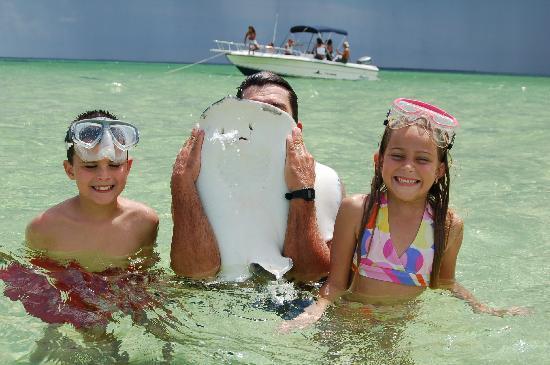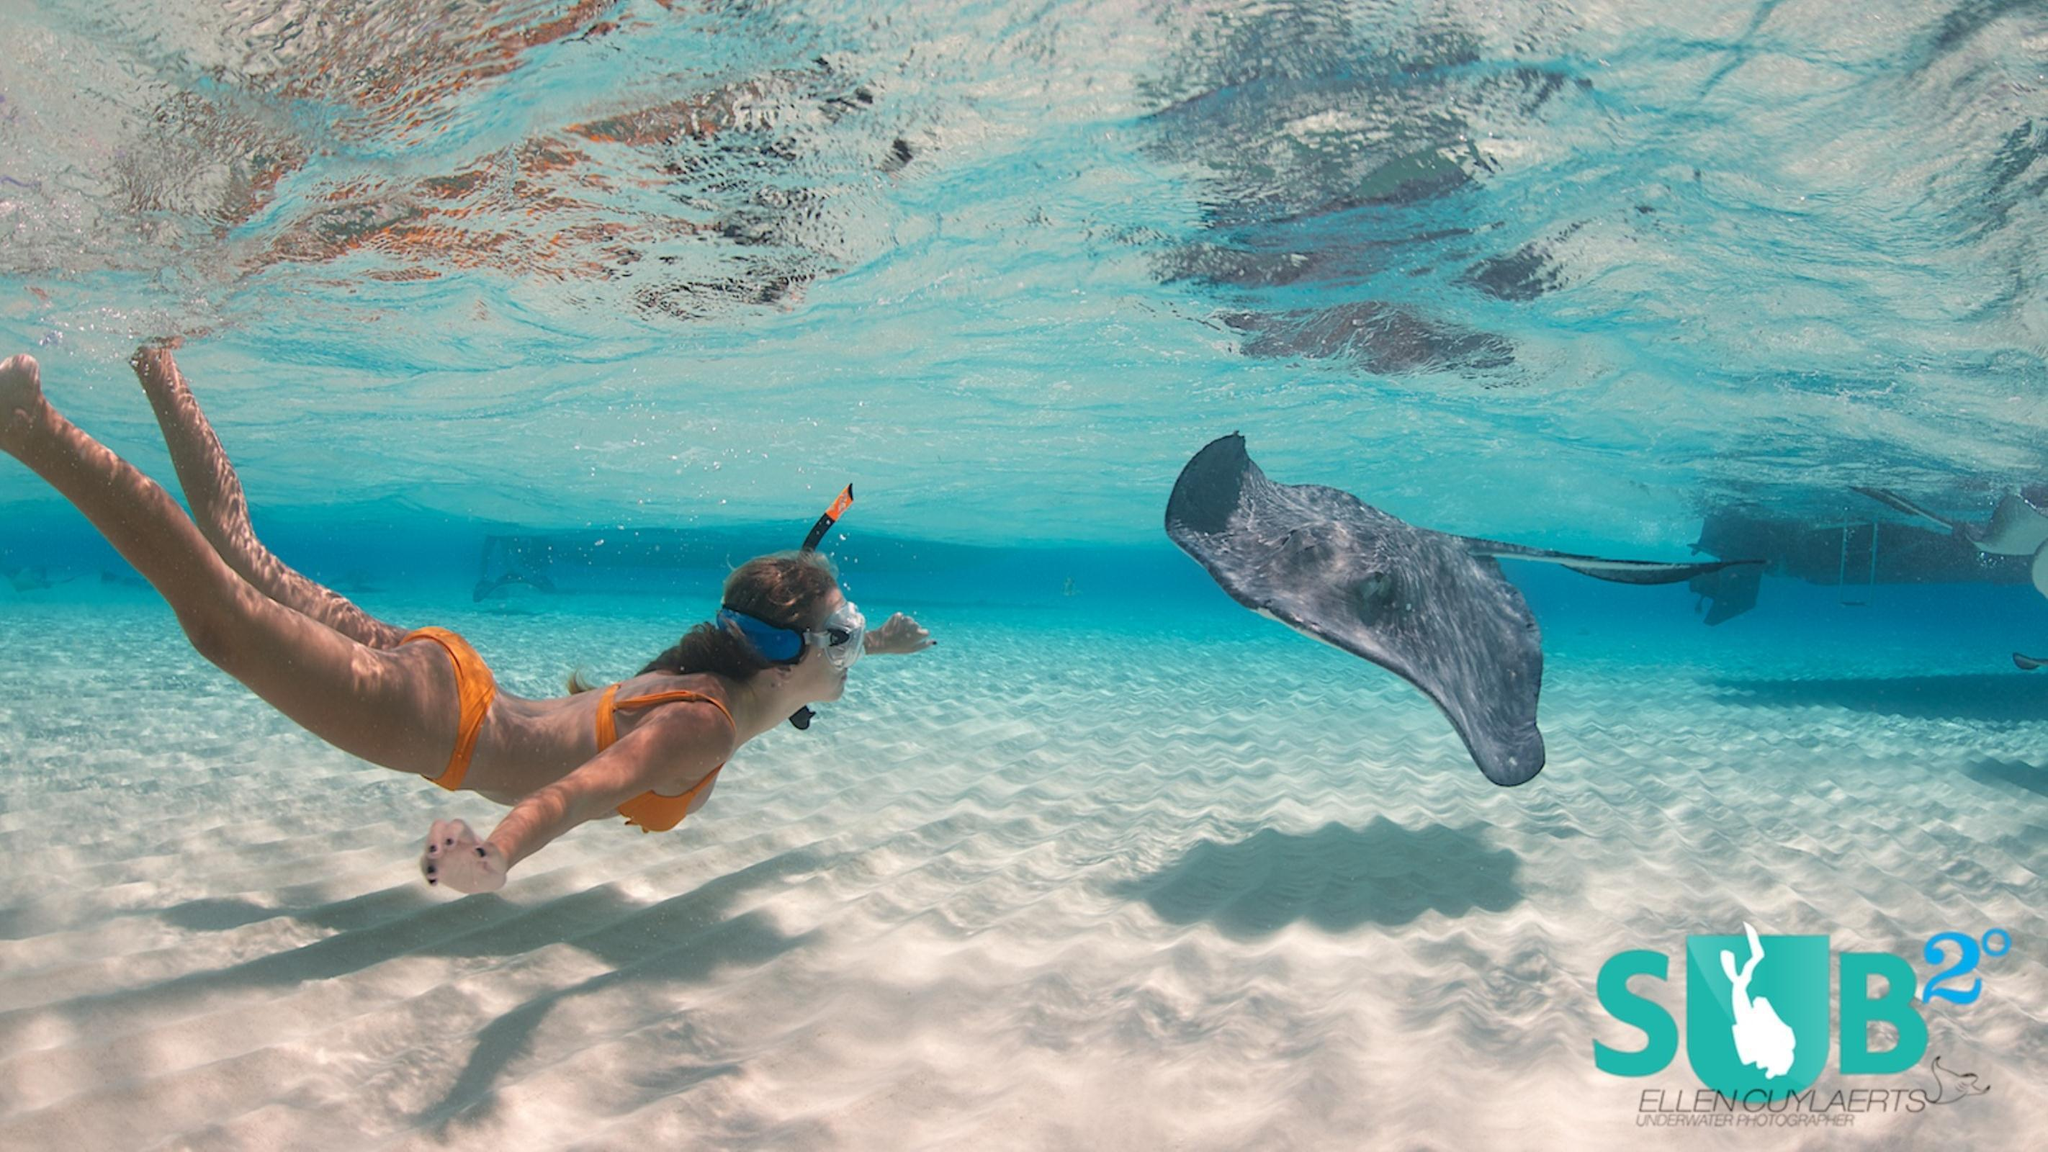The first image is the image on the left, the second image is the image on the right. Analyze the images presented: Is the assertion "The left image includes multiple people in the foreground, including a person with a stingray over part of their face." valid? Answer yes or no. Yes. The first image is the image on the left, the second image is the image on the right. Evaluate the accuracy of this statement regarding the images: "In at least one image there is a man holding a stingray to the left of a little girl with goggles.". Is it true? Answer yes or no. Yes. 